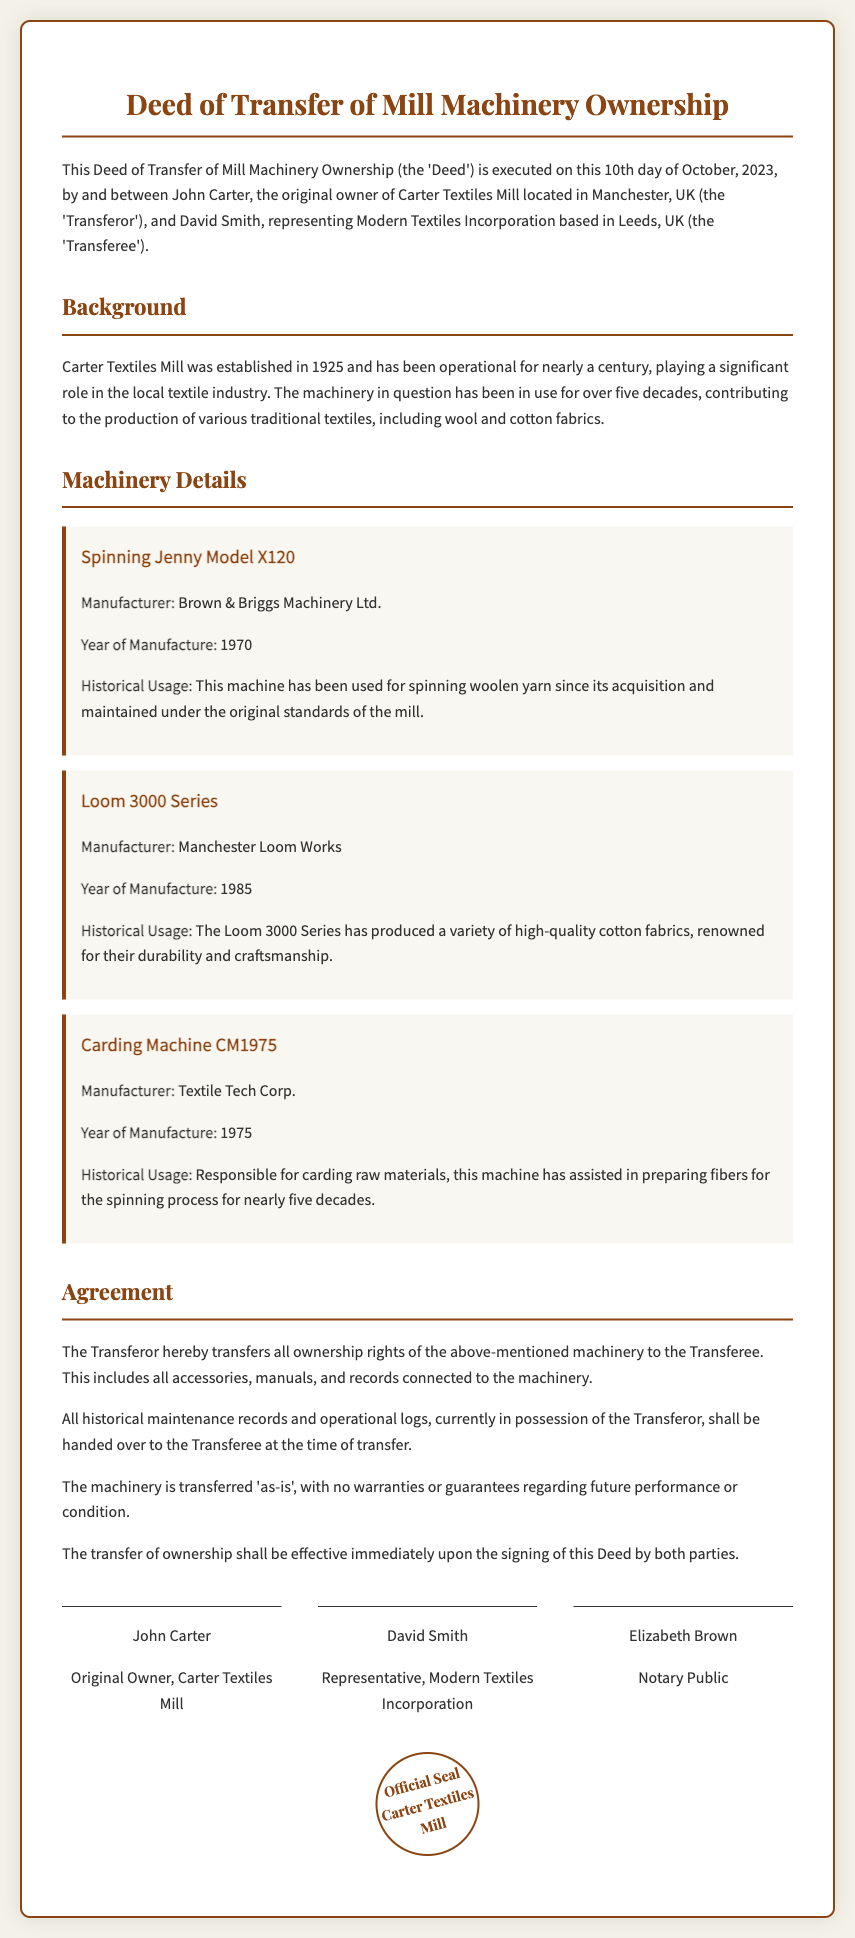What is the date of the deed execution? The deed was executed on the 10th day of October, 2023, as stated in the introduction.
Answer: 10th October, 2023 Who is the Transferor of the machinery? The Transferor, John Carter, is identified in the introduction as the original owner.
Answer: John Carter What is the model of the carding machine? The model is mentioned as Carding Machine CM1975 in the machinery section.
Answer: CM1975 How many years has the Spinning Jenny Model X120 been in use? The Spinning Jenny has been in use for over five decades, as specified in the historical usage details.
Answer: Over five decades What are the names of the parties who signed the deed? The signatories listed are John Carter, David Smith, and Elizabeth Brown, as mentioned in the signature section.
Answer: John Carter, David Smith, Elizabeth Brown What type of textile has the Loom 3000 Series produced? The Loom 3000 Series has produced high-quality cotton fabrics, detailed in the historical usage.
Answer: Cotton fabrics What is the transfer condition of the machinery? The agreement specifies that the machinery is transferred 'as-is,' indicating no warranties are given.
Answer: As-is In which city is Carter Textiles Mill located? The document states that Carter Textiles Mill is located in Manchester, UK.
Answer: Manchester, UK 